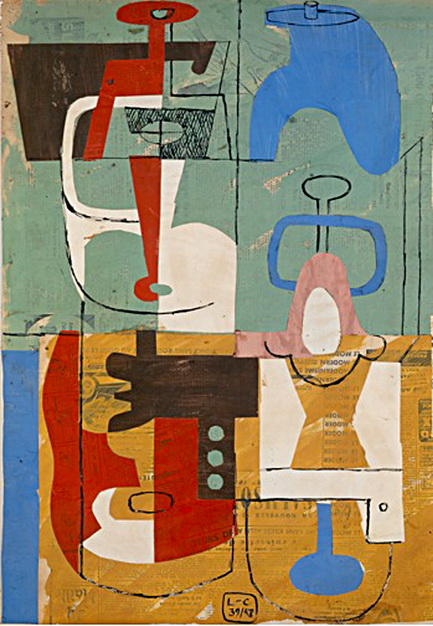Describe how this artwork could be used as a city mural. As a city mural, this abstract artwork would bring a burst of color and energy to the urban environment. Its vibrant and dynamic composition would transform a blank wall into a captivating piece of public art, enriching the visual landscape of the city. The geometric shapes and bold colors would add a contemporary and modern touch, resonating well with the city's spirit of innovation and creativity.

Placed in a prominent location, such as a busy intersection or a cultural district, the mural would attract residents and visitors alike, inviting them to pause and appreciate its beauty. The interplay of colors and shapes would create a sense of movement and rhythm, contributing to the lively atmosphere of the city. Whether viewed from a distance or up close, the mural would offer a constantly changing perspective, encouraging repeated viewing and deeper contemplation.

In summary, this artwork, as a city mural, would not only beautify the urban space but also inspire and uplift the community, fostering a sense of pride and connection through the shared experience of art. 